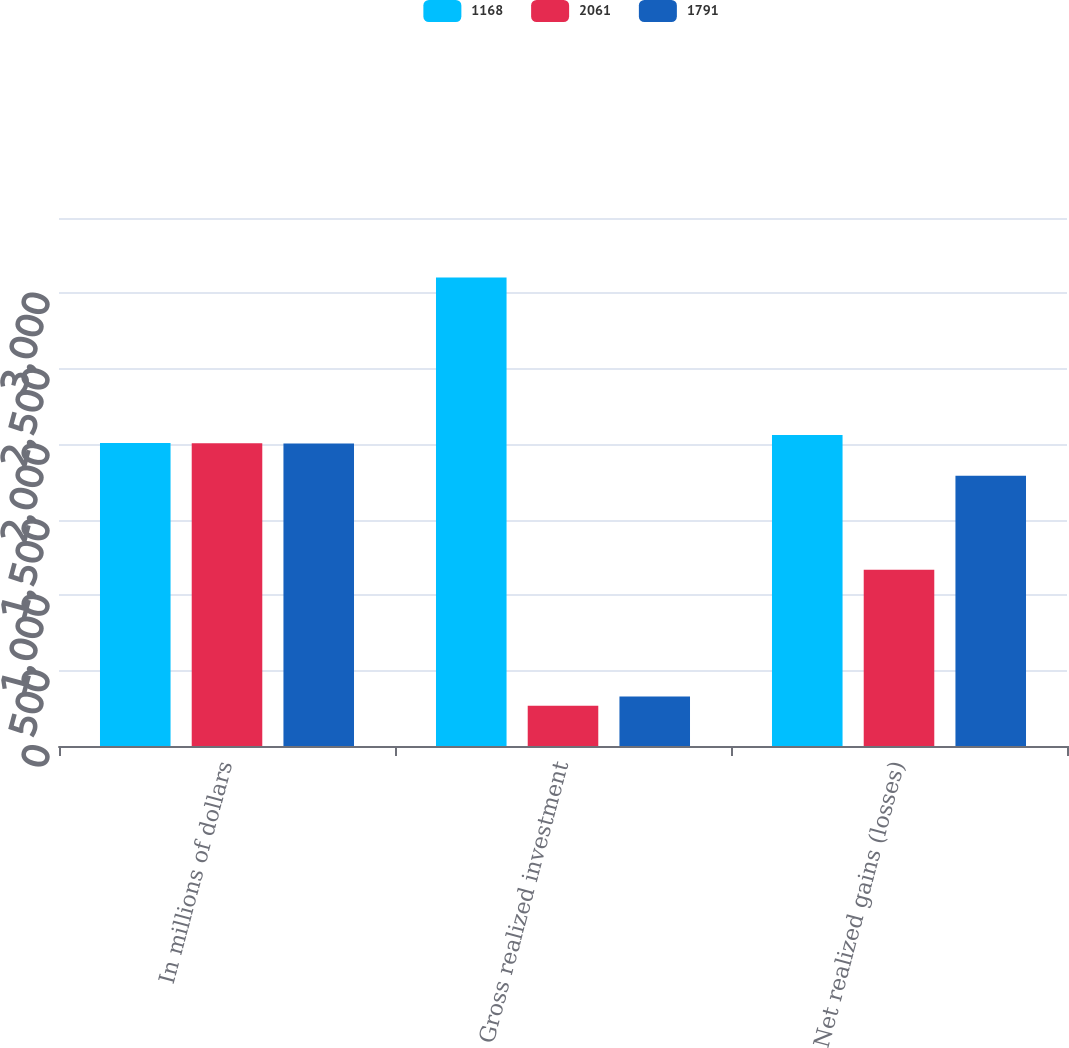<chart> <loc_0><loc_0><loc_500><loc_500><stacked_bar_chart><ecel><fcel>In millions of dollars<fcel>Gross realized investment<fcel>Net realized gains (losses)<nl><fcel>1168<fcel>2008<fcel>3105<fcel>2061<nl><fcel>2061<fcel>2007<fcel>267<fcel>1168<nl><fcel>1791<fcel>2006<fcel>328<fcel>1791<nl></chart> 